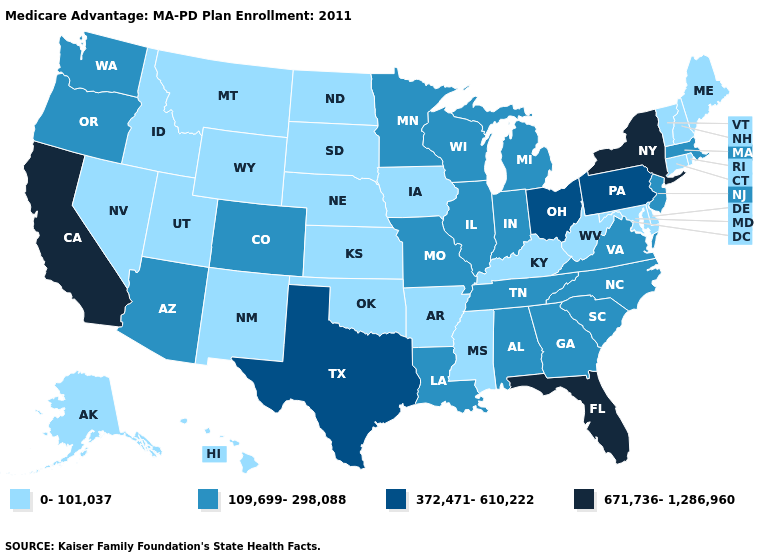Among the states that border Illinois , which have the lowest value?
Be succinct. Iowa, Kentucky. Among the states that border Maryland , which have the lowest value?
Concise answer only. Delaware, West Virginia. Which states have the highest value in the USA?
Be succinct. California, Florida, New York. What is the value of Idaho?
Keep it brief. 0-101,037. What is the highest value in states that border Oklahoma?
Give a very brief answer. 372,471-610,222. Name the states that have a value in the range 0-101,037?
Concise answer only. Alaska, Arkansas, Connecticut, Delaware, Hawaii, Iowa, Idaho, Kansas, Kentucky, Maryland, Maine, Mississippi, Montana, North Dakota, Nebraska, New Hampshire, New Mexico, Nevada, Oklahoma, Rhode Island, South Dakota, Utah, Vermont, West Virginia, Wyoming. Name the states that have a value in the range 109,699-298,088?
Be succinct. Alabama, Arizona, Colorado, Georgia, Illinois, Indiana, Louisiana, Massachusetts, Michigan, Minnesota, Missouri, North Carolina, New Jersey, Oregon, South Carolina, Tennessee, Virginia, Washington, Wisconsin. What is the value of Vermont?
Keep it brief. 0-101,037. Is the legend a continuous bar?
Be succinct. No. What is the value of Connecticut?
Write a very short answer. 0-101,037. Does Iowa have the same value as Vermont?
Concise answer only. Yes. Name the states that have a value in the range 109,699-298,088?
Short answer required. Alabama, Arizona, Colorado, Georgia, Illinois, Indiana, Louisiana, Massachusetts, Michigan, Minnesota, Missouri, North Carolina, New Jersey, Oregon, South Carolina, Tennessee, Virginia, Washington, Wisconsin. Does the first symbol in the legend represent the smallest category?
Keep it brief. Yes. Does the map have missing data?
Quick response, please. No. Does the first symbol in the legend represent the smallest category?
Keep it brief. Yes. 